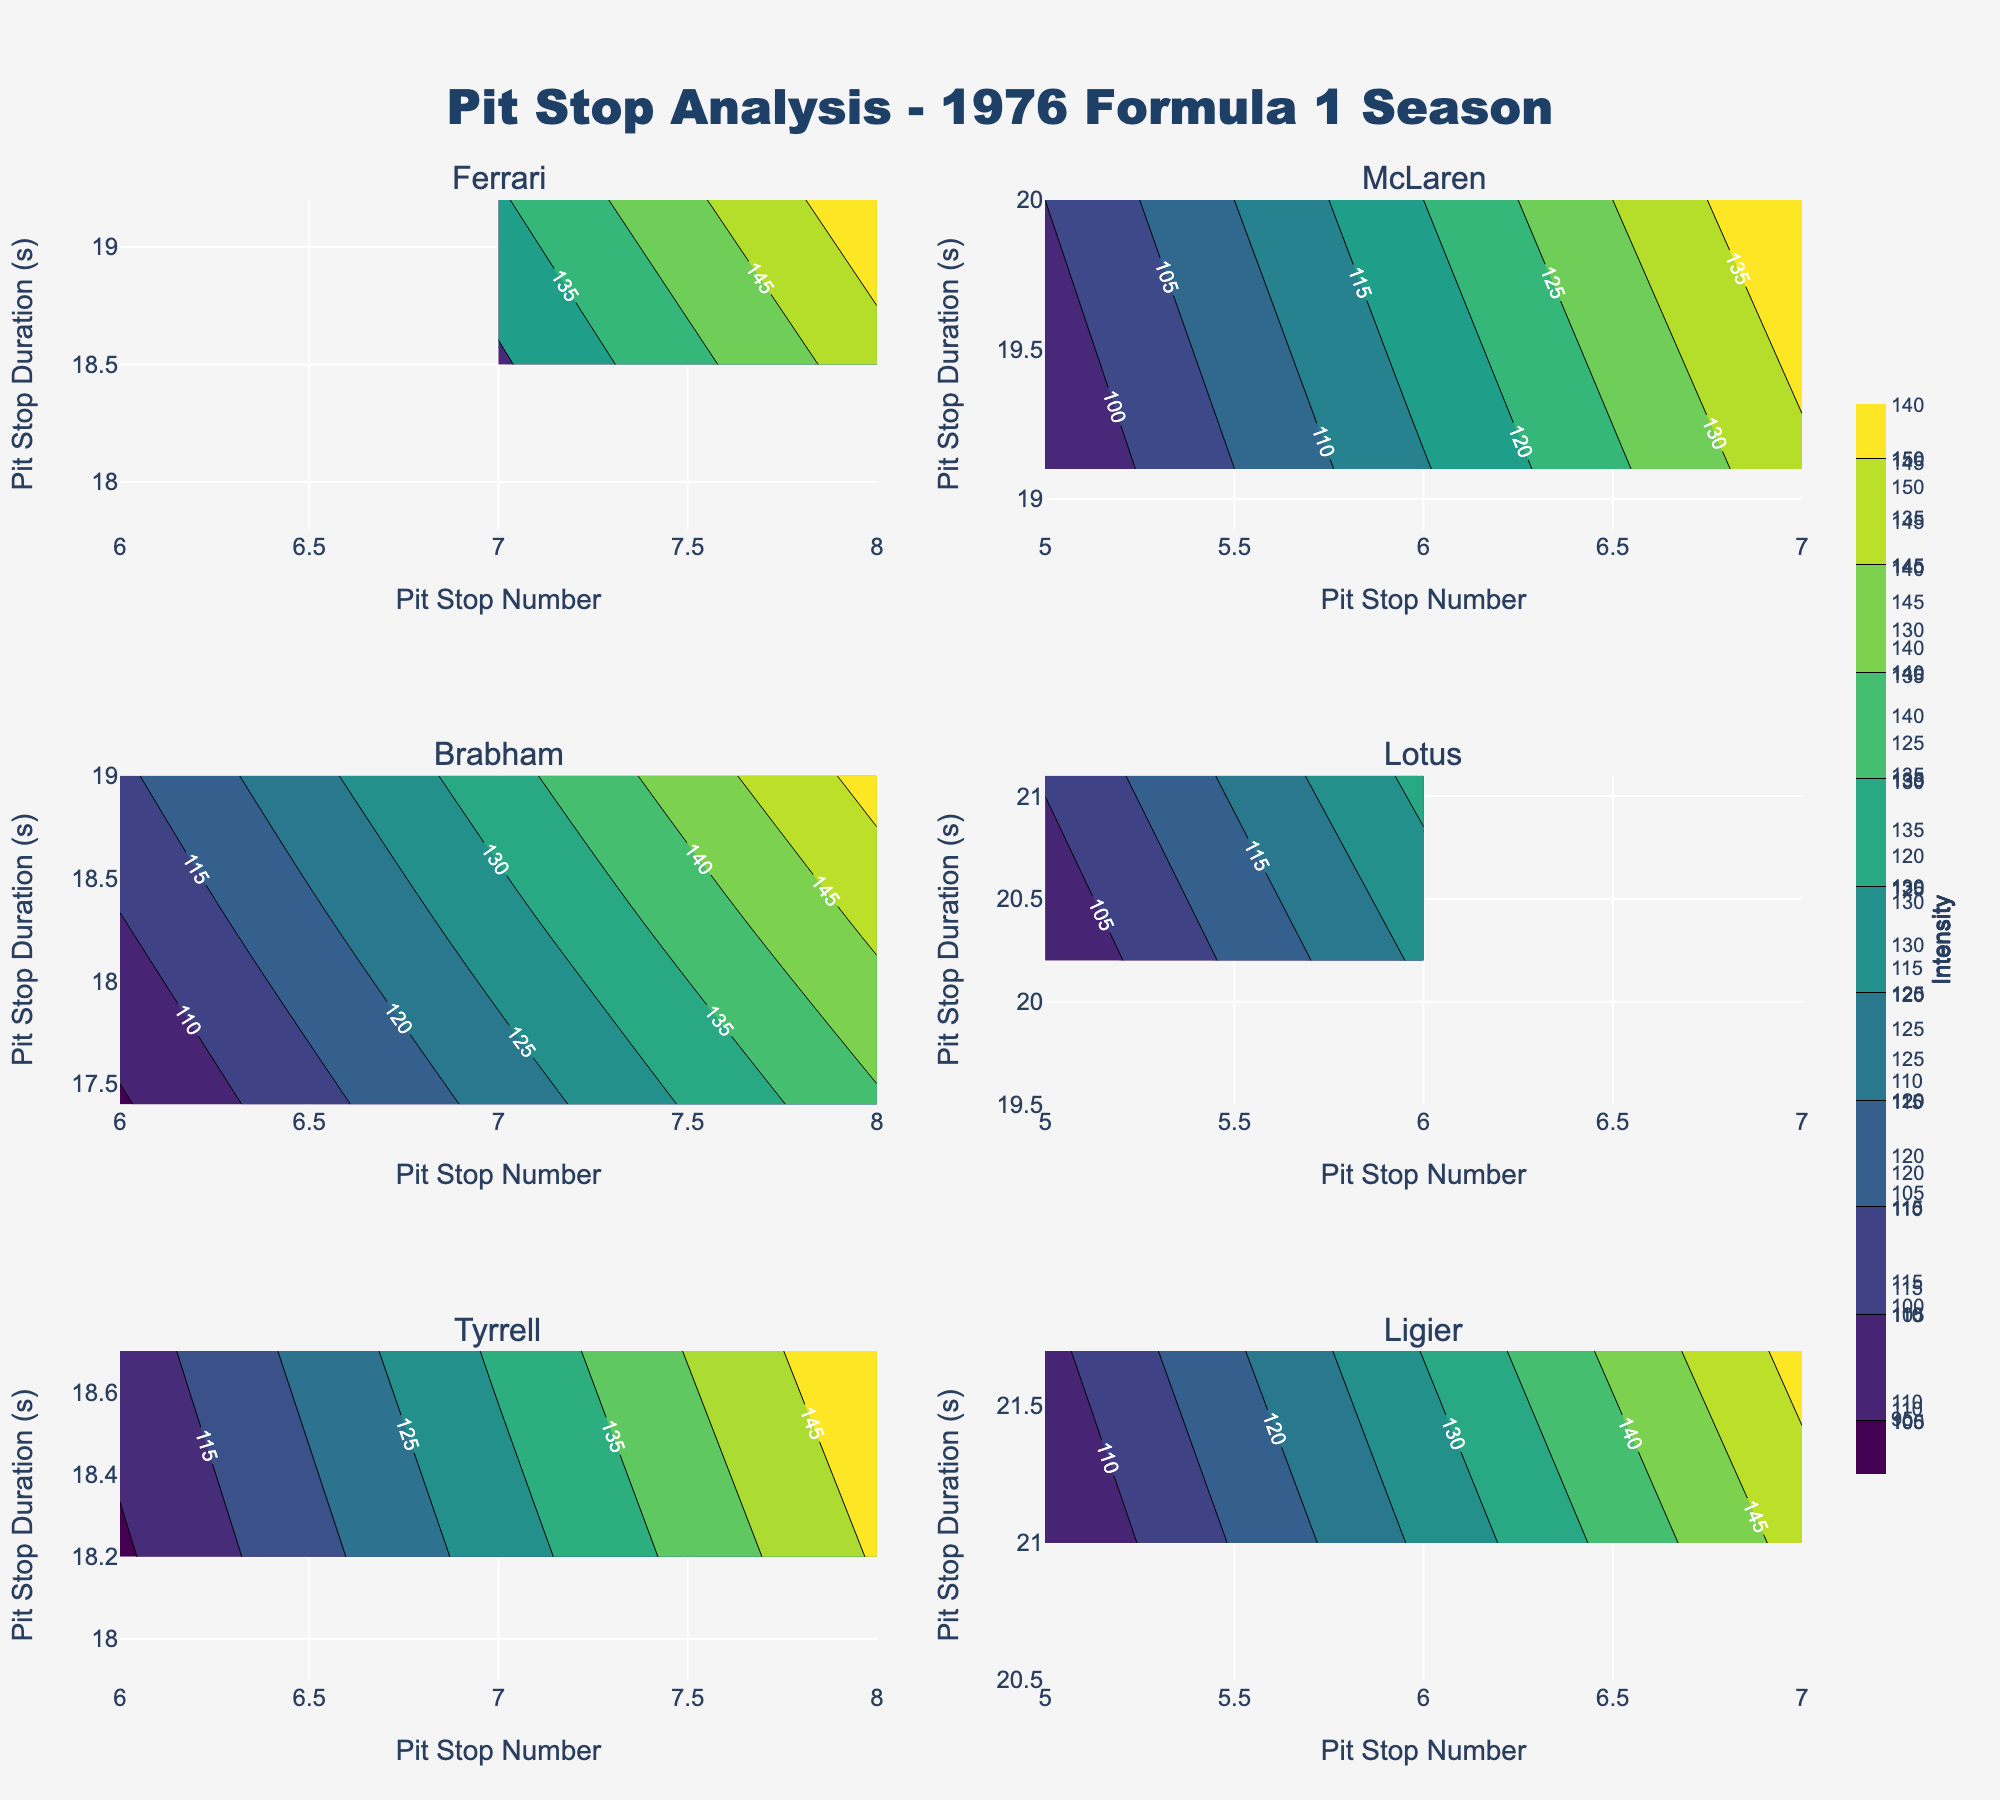What is the main title of the figure? The main title is typically displayed at the top of the plot. In this case, it would be visible and can be read directly.
Answer: Pit Stop Analysis - 1976 Formula 1 Season How many subplots are there in total? Count the number of individual contour plots present in the visual, each representing a team.
Answer: 6 Which team has the highest number of pit stops recorded in their subplot? Examine the x-axis of each subplot for the maximum value. Ferrari reaches 8 pit stops, tied with Brabham and Tyrrell.
Answer: Ferrari, Brabham, and Tyrrell What is the range of pit stop durations observed for McLaren? Check the y-axis values on McLaren's subplot to identify the minimum and maximum pit stop durations.
Answer: 18.9 to 20.0 seconds Compare the pit stop durations for Lotus and Ligier. Which team has generally longer pit stop durations? Examine the y-axis range for both subplots and note that Ligier's durations are between 20.5 and 21.7 seconds, while Lotus' are between 20.2 and 21.1 seconds.
Answer: Ligier Based on the contours, which team's pit stops appear to be most evenly distributed across different values? Look for evenly spaced contour lines without abrupt changes. Tyrrell's subplot shows smoother and more evenly spaced contours.
Answer: Tyrrell What is the color scheme used for the contour plots? Identify the color pattern in the plot, such as viridis, compared to familiar color schemes.
Answer: Viridis In Tyrrell's subplot, what pit stop duration is most frequently observed? Identify the contour line with the highest density, which indicates the most frequent value. This demonstrates high frequency around 18 seconds.
Answer: 18 seconds If you combine Ferrari’s and McLaren's longest recorded pit stop durations, what is the total? Add McLaren's maximum (20.0) and Ferrari's maximum (19.2) pit stop durations.
Answer: 39.2 seconds 